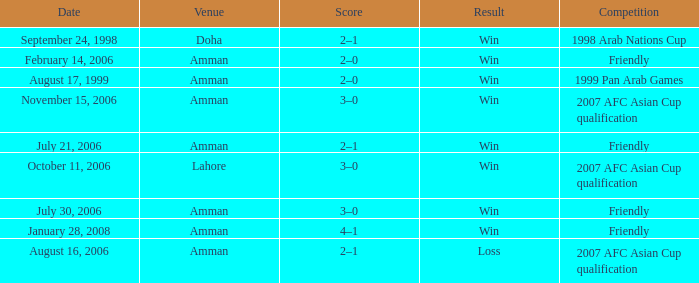Which competition took place on October 11, 2006? 2007 AFC Asian Cup qualification. 